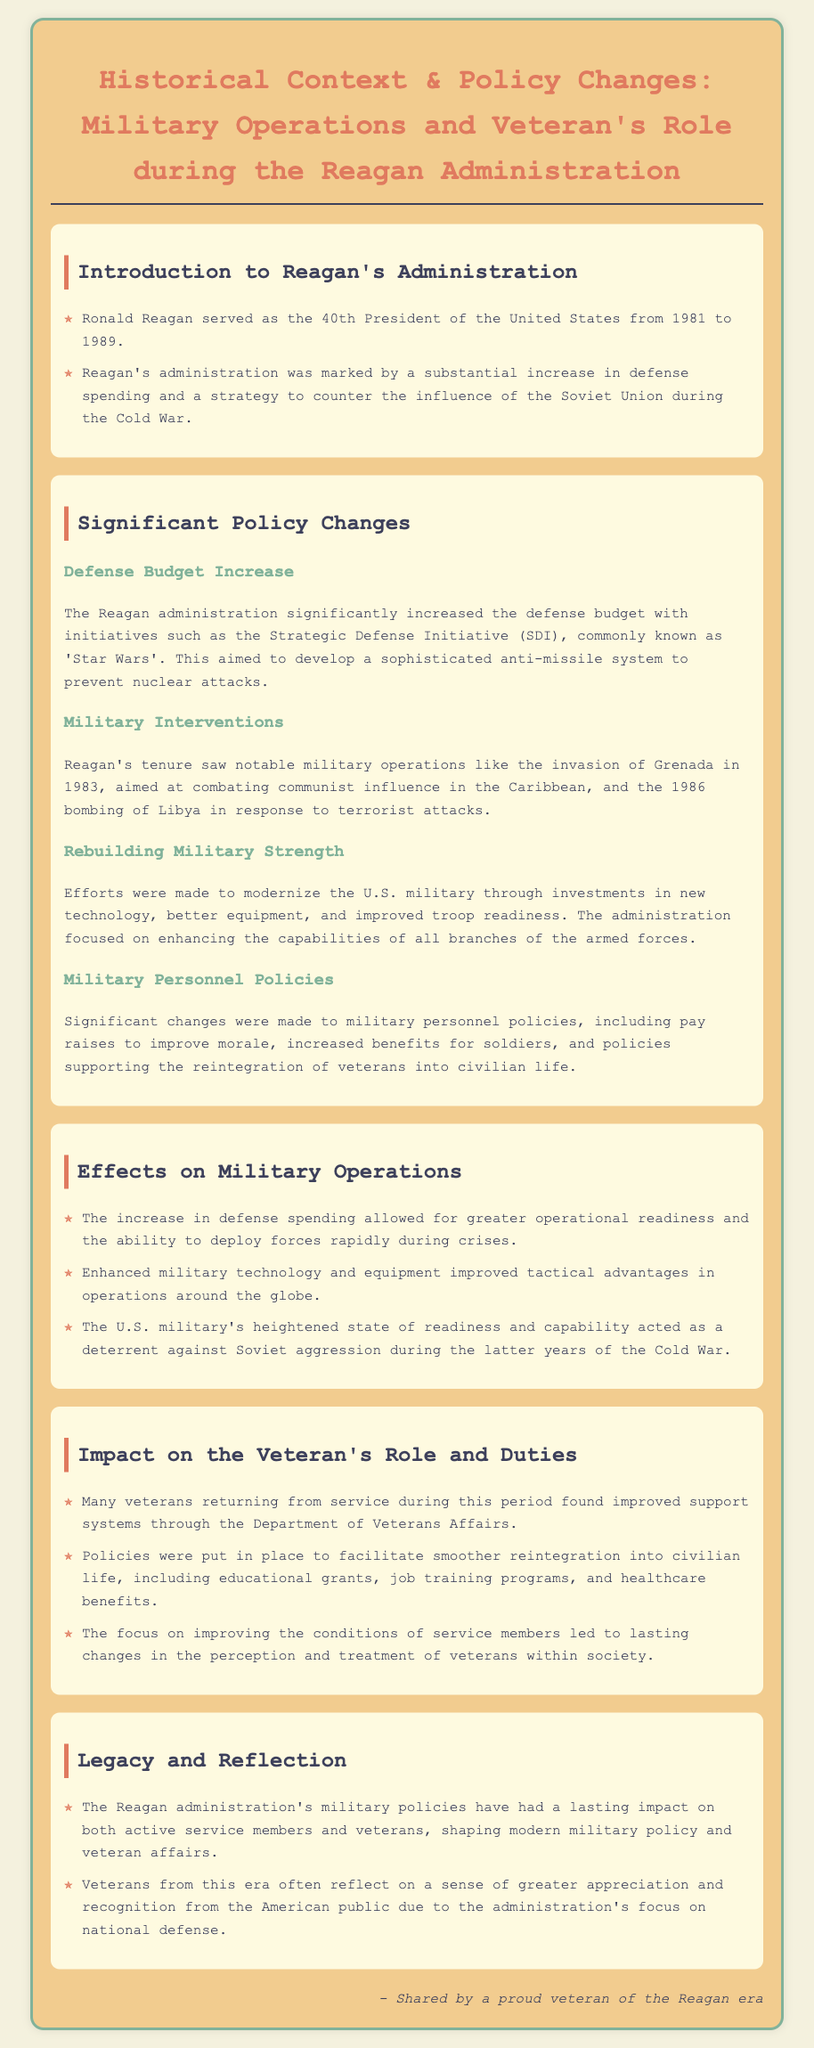What years did Reagan serve as President? The document states that Ronald Reagan served as the 40th President of the United States from 1981 to 1989.
Answer: 1981 to 1989 What was the Strategic Defense Initiative aimed at? The document mentions that the Strategic Defense Initiative aimed to develop a sophisticated anti-missile system to prevent nuclear attacks.
Answer: Prevent nuclear attacks Which military operation occurred in 1983? The document lists the invasion of Grenada as a notable military operation during Reagan's tenure in 1983.
Answer: Invasion of Grenada What significant impact did defense spending have on military readiness? The document states that the increase in defense spending allowed for greater operational readiness and the ability to deploy forces rapidly during crises.
Answer: Greater operational readiness What support systems were improved for veterans? The document mentions that many veterans found improved support systems through the Department of Veterans Affairs during this period.
Answer: Department of Veterans Affairs What example of a job training program was implemented for veterans? The document notes that educational grants and job training programs were part of the policies supporting the reintegration of veterans into civilian life.
Answer: Job training programs How did the U.S. military's readiness affect Soviet aggression? The document indicates that the U.S. military's heightened state of readiness acted as a deterrent against Soviet aggression during the latter years of the Cold War.
Answer: Deterrent against Soviet aggression What legislation improved pay for military personnel? The document states that significant changes were made to military personnel policies, including pay raises to improve morale.
Answer: Pay raises What type of public perception changed due to military policies? The document mentions that veterans from this era reflect on a sense of greater appreciation and recognition from the American public due to the administration's focus on national defense.
Answer: Greater appreciation and recognition 